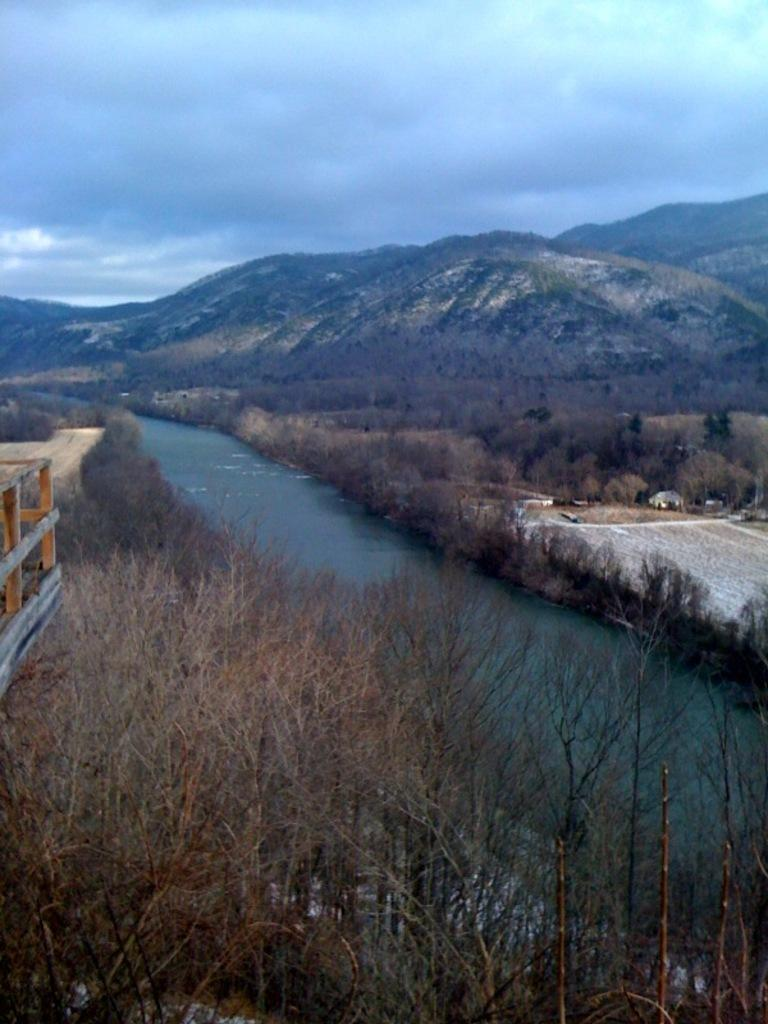What type of natural landform can be seen in the image? There are hills in the image. What type of vegetation is present in the image? There are trees in the image. What body of water is visible in the image? There is a lake in the image. What type of man-made structure is present? There is a building in the image. What type of path is visible in the image? There is a path in the image. What is visible at the top of the image? The sky is visible at the top of the image. Can you tell me how many bees are flying over the lake in the image? There are no bees present in the image; it only features hills, trees, a lake, a building, a path, and the sky. What type of yak can be seen grazing on the hill in the image? There are no yaks present in the image; it only features hills, trees, a lake, a building, a path, and the sky. 